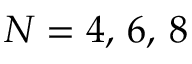<formula> <loc_0><loc_0><loc_500><loc_500>N = 4 , \, 6 , \, 8</formula> 